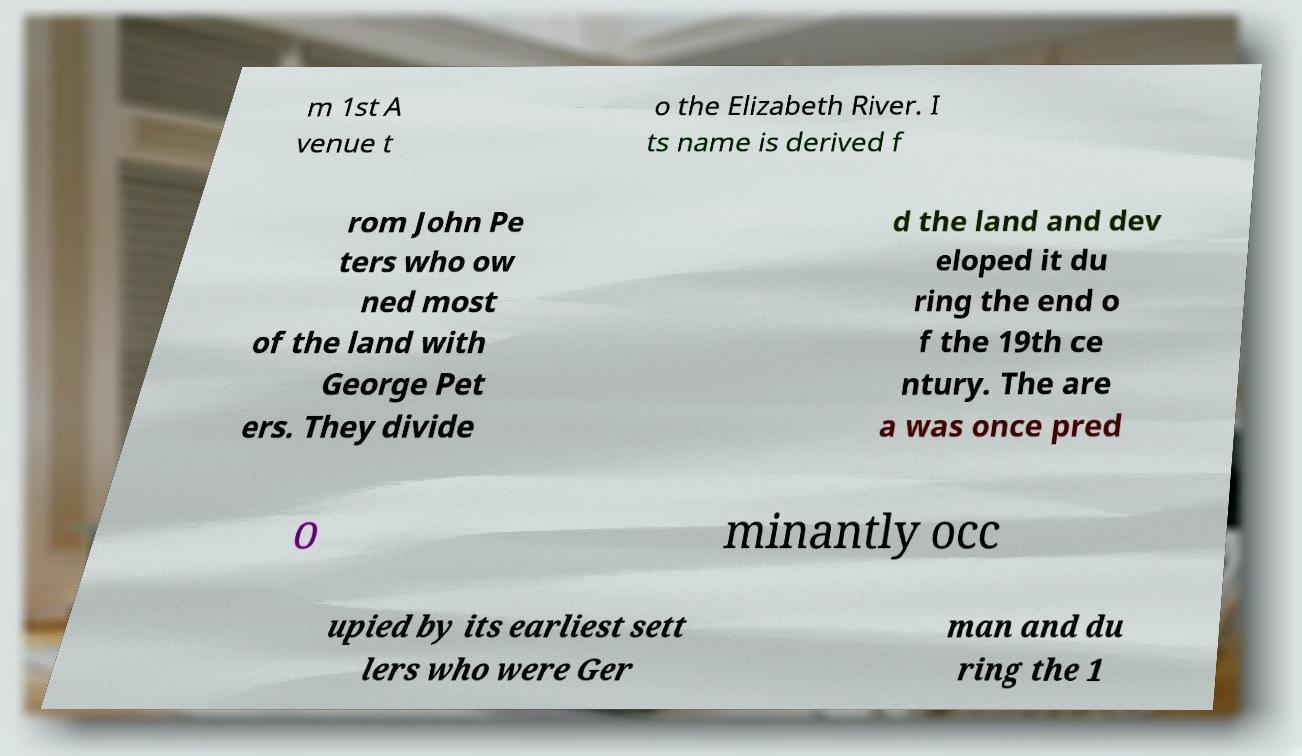Please read and relay the text visible in this image. What does it say? m 1st A venue t o the Elizabeth River. I ts name is derived f rom John Pe ters who ow ned most of the land with George Pet ers. They divide d the land and dev eloped it du ring the end o f the 19th ce ntury. The are a was once pred o minantly occ upied by its earliest sett lers who were Ger man and du ring the 1 